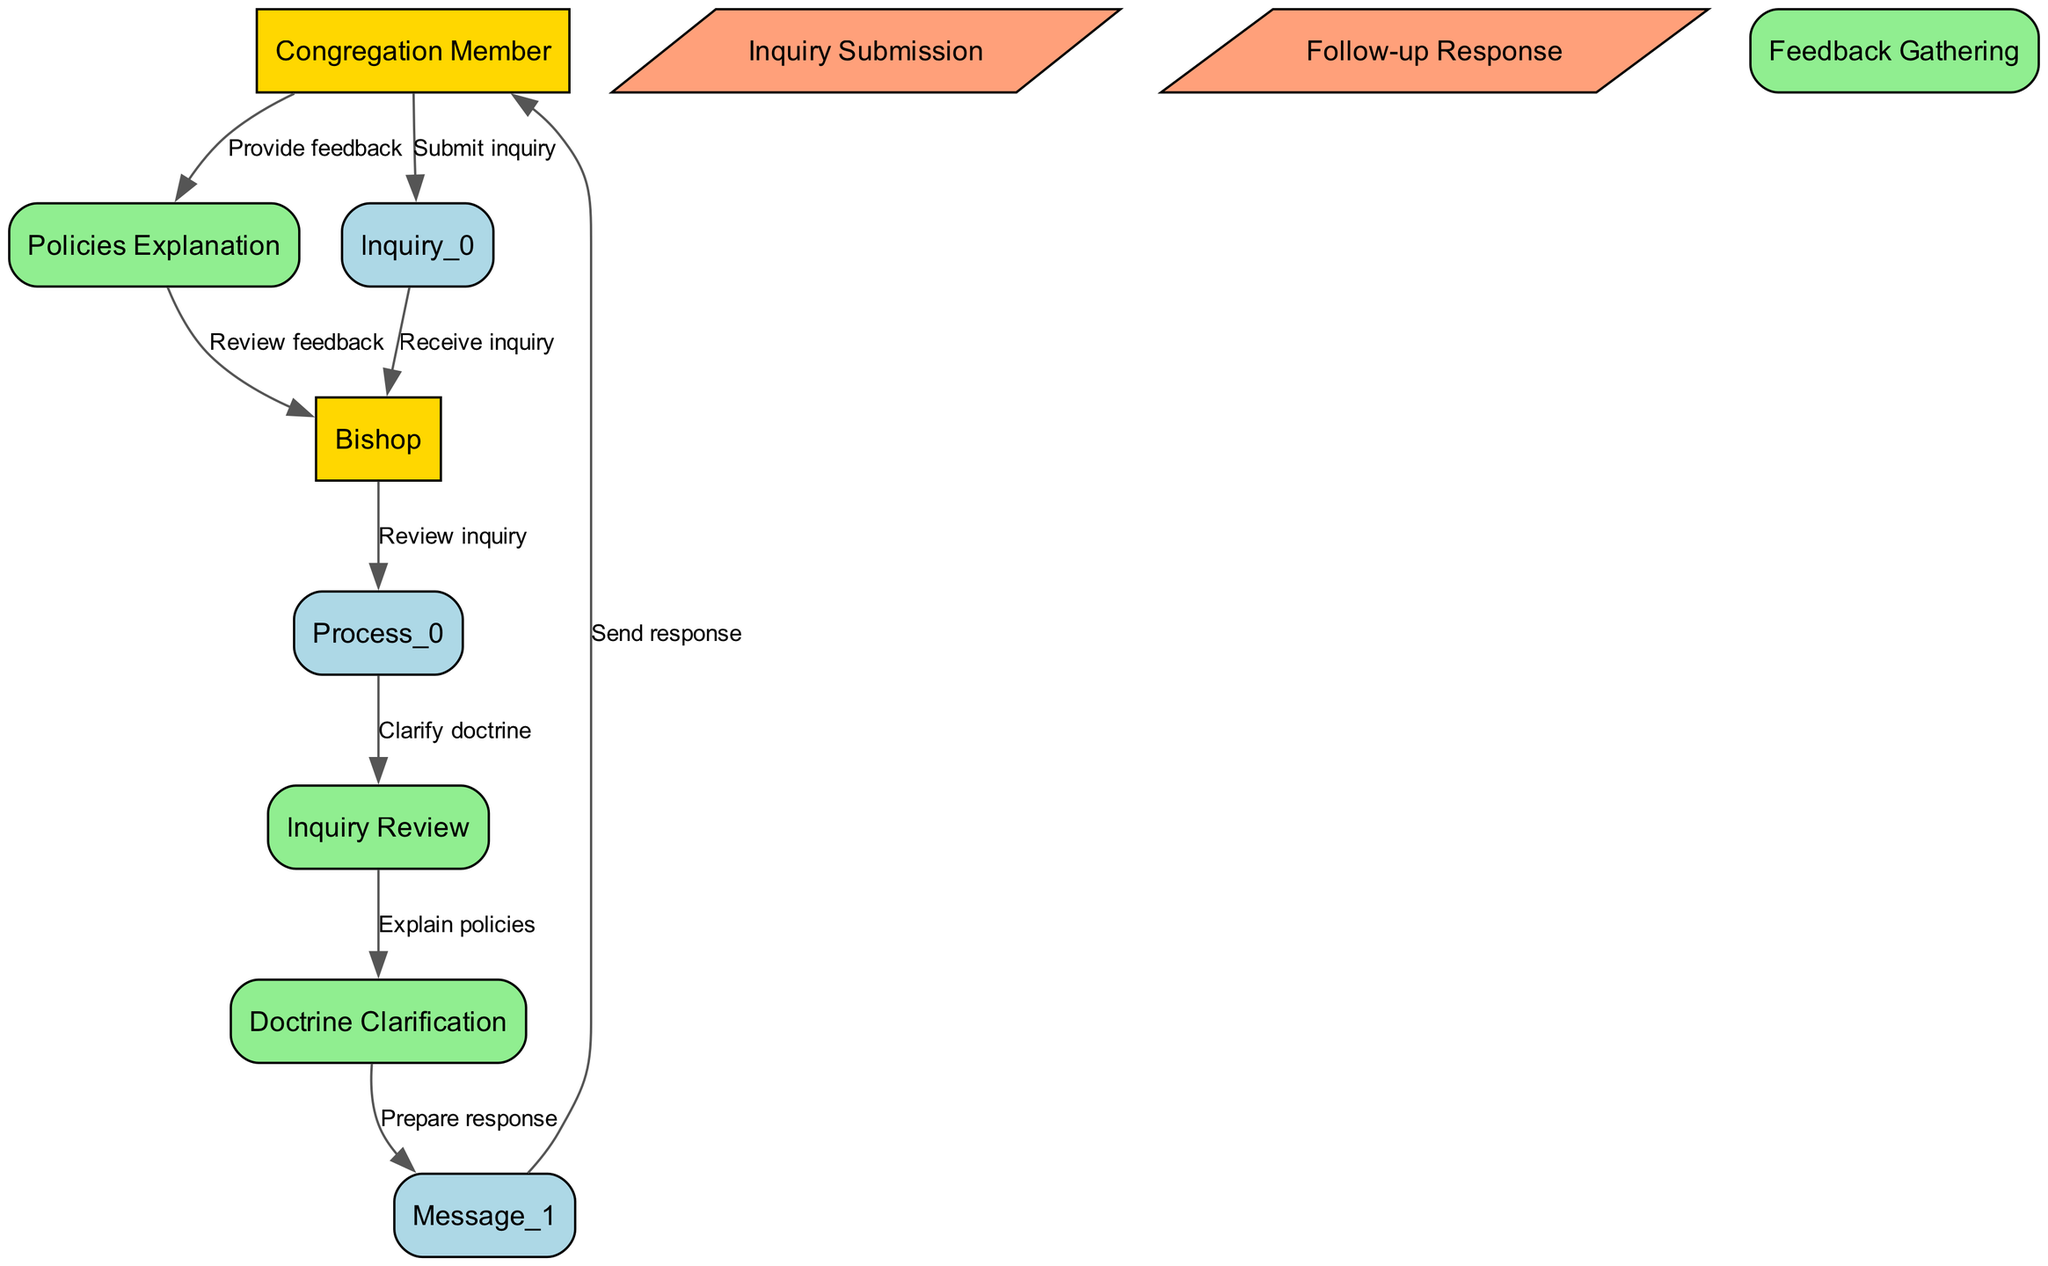What is the first action taken by the Congregation Member? The first action in the diagram shows the Congregation Member submitting an inquiry. This is indicated by the edge connecting the Congregation Member to the Inquiry Submission node.
Answer: Submit inquiry How many processes are involved in handling an inquiry? The diagram features three distinct processes: Inquiry Review, Doctrine Clarification, and Policies Explanation, indicating a total of three processes in the handling of an inquiry.
Answer: Three What does the Bishop do after receiving the inquiry? After receiving the inquiry from the Congregation Member, the Bishop reviews the inquiry, as denoted by the edge from the Bishop to the Inquiry Review process node.
Answer: Review inquiry What follows the Policies Explanation process? The Policies Explanation process is followed by the preparation of a response, which is represented by an edge connecting Policies Explanation to Follow-up Response in the diagram.
Answer: Prepare response What feedback action is performed by the Congregation Member? The Congregation Member provides feedback after receiving the response, as shown by the edge connecting the Congregation Member to the Feedback Gathering process node in the diagram.
Answer: Provide feedback What is the role of the Inquiry Submission message? The Inquiry Submission message serves as the initial communication from the Congregation Member to the Bishop, marking the start of the inquiry handling process in the sequence diagram.
Answer: Initial communication How many total edges are present in the diagram? The diagram contains a total of eight edges, each representing the interaction or flow between different nodes. By counting each connection represented in the diagram, we conclude there are eight edges.
Answer: Eight What action comes immediately after Doctrine Clarification? Following the Doctrine Clarification process, the next action is to explain policies, as indicated by the direct connection from the Doctrine Clarification process to the Policies Explanation process node.
Answer: Explain policies Which actor sends the final response? The final response is sent from the Bishop to the Congregation Member, which is shown in the diagram by the edge connecting Follow-up Response to Congregation Member.
Answer: Bishop 